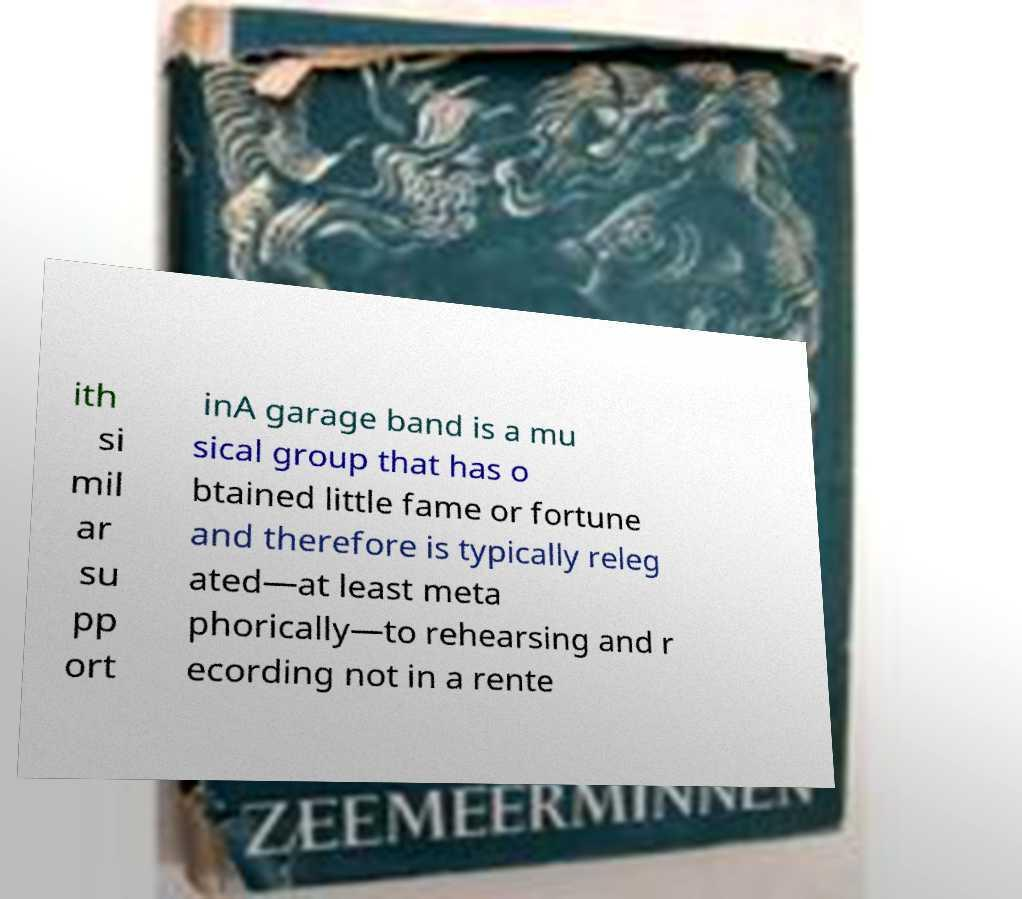Could you assist in decoding the text presented in this image and type it out clearly? ith si mil ar su pp ort inA garage band is a mu sical group that has o btained little fame or fortune and therefore is typically releg ated—at least meta phorically—to rehearsing and r ecording not in a rente 